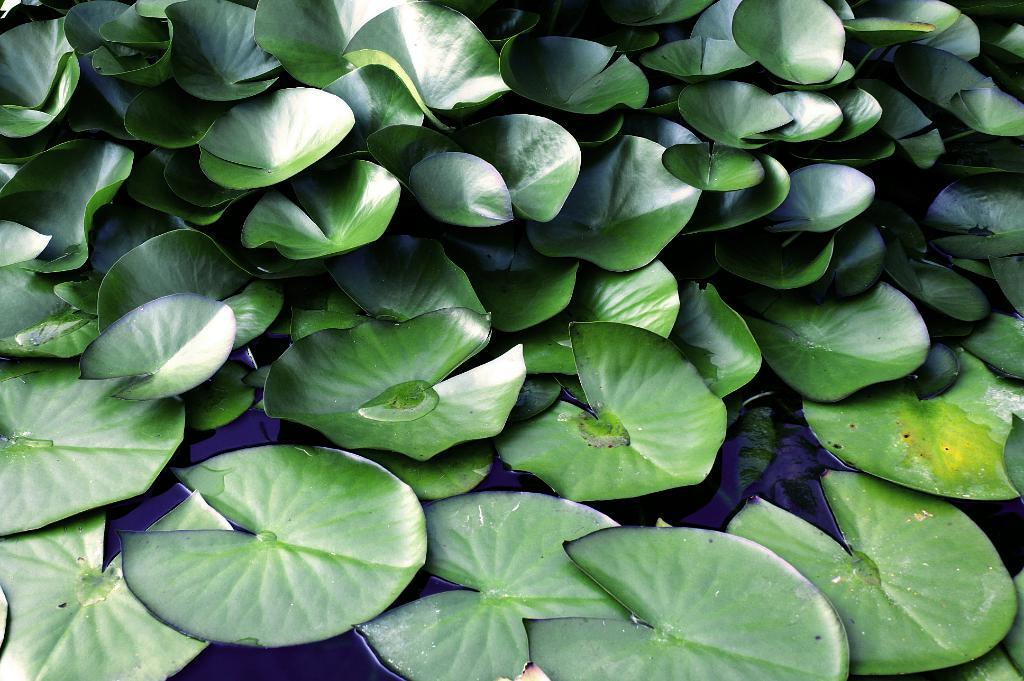What is present on the water surface at the bottom side of the image? There are leaves on the water surface at the bottom side of the image. What can be seen at the top side of the image? There are leaves at the top side of the image. How many mice can be seen walking on the leaves at the top side of the image? There are no mice present in the image, and therefore no such activity can be observed. 